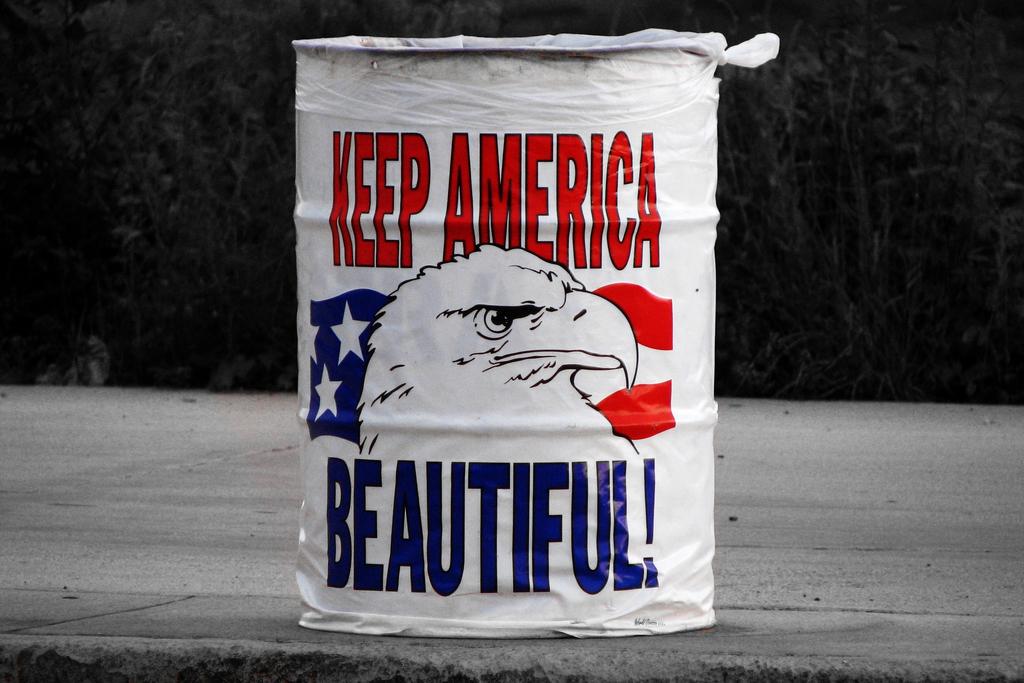How should america be kept looking?
Your answer should be very brief. Beautiful. 